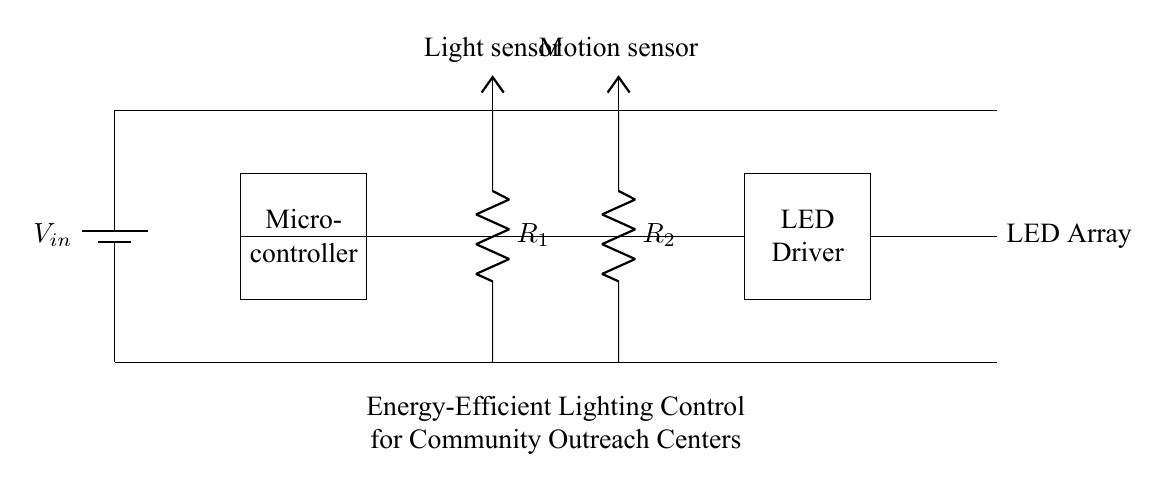What is the input voltage for this circuit? The input voltage is represented by \( V_{in} \) which is connected to the battery in the circuit. It indicates the power supply for the circuit. Without specific voltage values provided, it is typically a standard voltage like 5V or 12V based on common battery outputs.
Answer: \( V_{in} \) What type of sensors are included in the circuit? The circuit includes a light sensor and a motion sensor. These sensors are shown in the diagram, each represented by their respective labels. The light sensor is connected to a resistor \( R_1 \), and the motion sensor is connected to another resistor \( R_2 \).
Answer: Light and motion How many components are directly involved in controlling the LED? There are three components directly involved in controlling the LED: the microcontroller, the LED driver, and the LED array itself. The microcontroller processes inputs from the sensors, while the LED driver controls the LED array based on signals from the microcontroller.
Answer: Three What is the purpose of the microcontroller in this circuit? The purpose of the microcontroller is to receive input from the light and motion sensors and make decisions about controlling the LED driver. It acts as the brain of the lighting control system, enabling energy-efficient lighting based on sensor data.
Answer: Control lights What is the relationship between the light sensor and the microcontroller? The light sensor provides feedback about ambient lighting conditions to the microcontroller, which then processes this information. If the light level is below a certain threshold, the microcontroller can command the LED driver to activate the LED array, resulting in energy-efficient lighting only when needed.
Answer: Input and control Which component would be responsible for reducing energy consumption in the lighting system? The LED driver is primarily responsible for reducing energy consumption in the lighting system. By regulating the power delivered to the LED array based on the commands from the microcontroller, it ensures that the LEDs are only lit when required and at optimal levels of brightness.
Answer: LED driver 